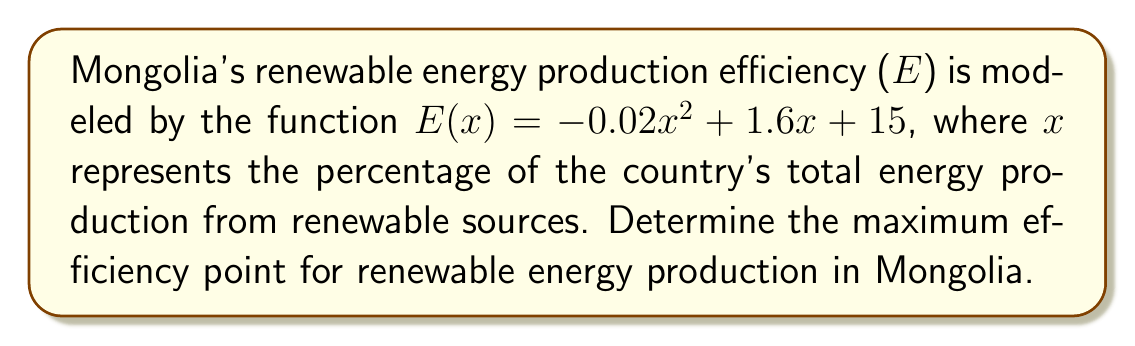Could you help me with this problem? To find the maximum efficiency point, we need to follow these steps:

1. Find the derivative of the efficiency function E(x):
   $$\frac{dE}{dx} = -0.04x + 1.6$$

2. Set the derivative equal to zero to find the critical point:
   $$-0.04x + 1.6 = 0$$
   $$-0.04x = -1.6$$
   $$x = 40$$

3. Verify that this critical point is a maximum by checking the second derivative:
   $$\frac{d^2E}{dx^2} = -0.04$$
   Since the second derivative is negative, the critical point is a maximum.

4. Calculate the maximum efficiency by plugging x = 40 into the original function:
   $$E(40) = -0.02(40)^2 + 1.6(40) + 15$$
   $$E(40) = -32 + 64 + 15 = 47$$

Therefore, the maximum efficiency point occurs when 40% of Mongolia's energy production comes from renewable sources, resulting in an efficiency of 47 units.
Answer: (40%, 47) 